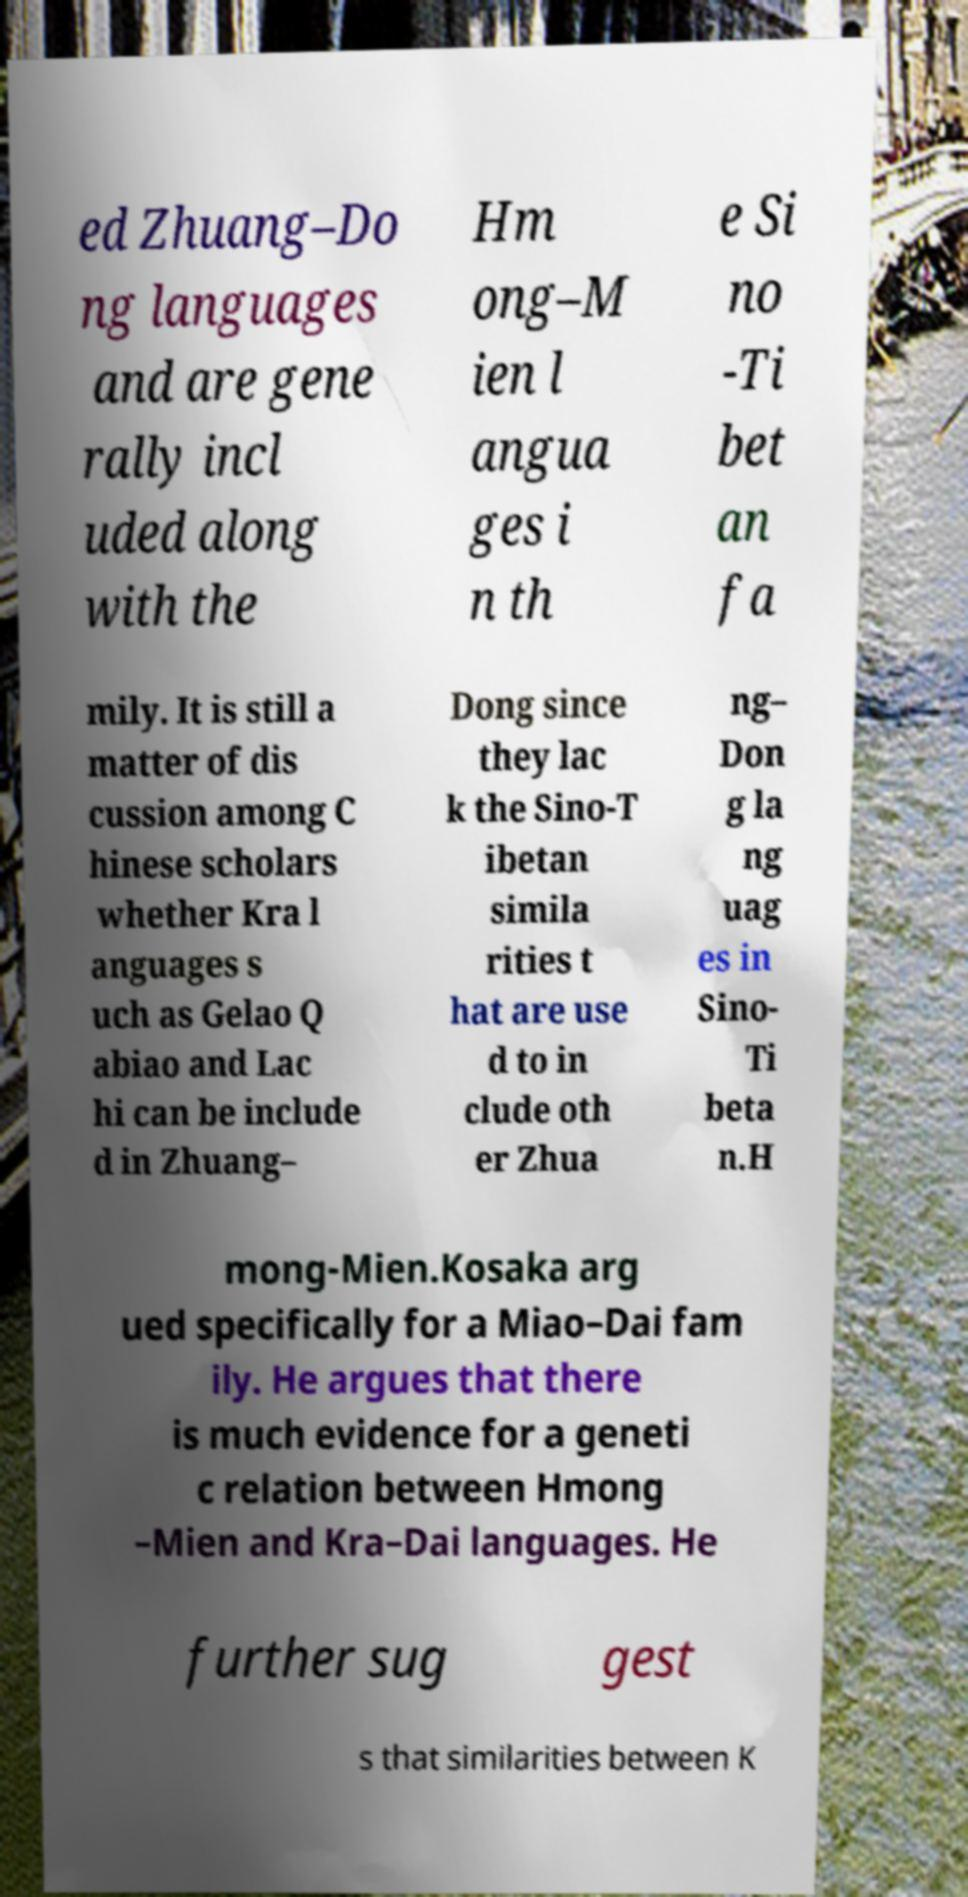There's text embedded in this image that I need extracted. Can you transcribe it verbatim? ed Zhuang–Do ng languages and are gene rally incl uded along with the Hm ong–M ien l angua ges i n th e Si no -Ti bet an fa mily. It is still a matter of dis cussion among C hinese scholars whether Kra l anguages s uch as Gelao Q abiao and Lac hi can be include d in Zhuang– Dong since they lac k the Sino-T ibetan simila rities t hat are use d to in clude oth er Zhua ng– Don g la ng uag es in Sino- Ti beta n.H mong-Mien.Kosaka arg ued specifically for a Miao–Dai fam ily. He argues that there is much evidence for a geneti c relation between Hmong –Mien and Kra–Dai languages. He further sug gest s that similarities between K 